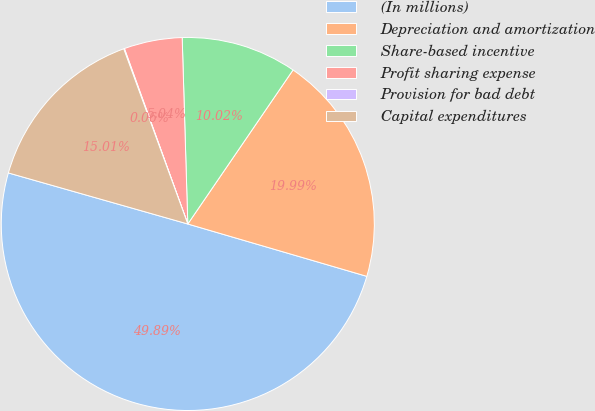Convert chart to OTSL. <chart><loc_0><loc_0><loc_500><loc_500><pie_chart><fcel>(In millions)<fcel>Depreciation and amortization<fcel>Share-based incentive<fcel>Profit sharing expense<fcel>Provision for bad debt<fcel>Capital expenditures<nl><fcel>49.89%<fcel>19.99%<fcel>10.02%<fcel>5.04%<fcel>0.06%<fcel>15.01%<nl></chart> 